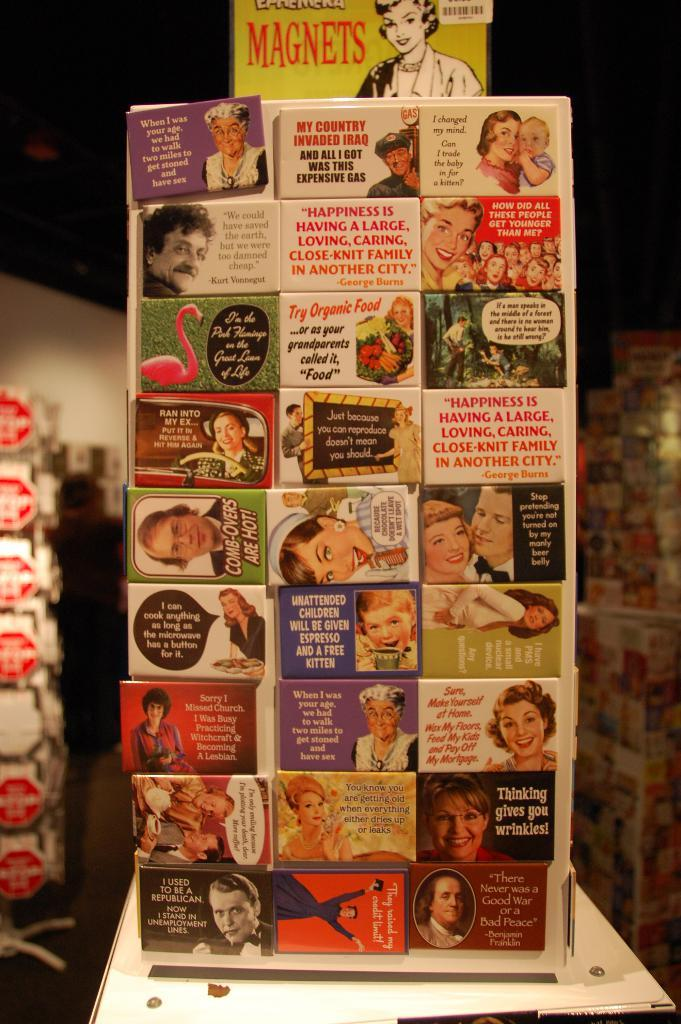What objects are in the foreground of the picture? There are stickers of magnets in the foreground of the picture. Can you describe the background of the image? The background of the image is blurred. What type of eggnog is being served in the image? There is no eggnog present in the image; it features stickers of magnets in the foreground and a blurred background. 